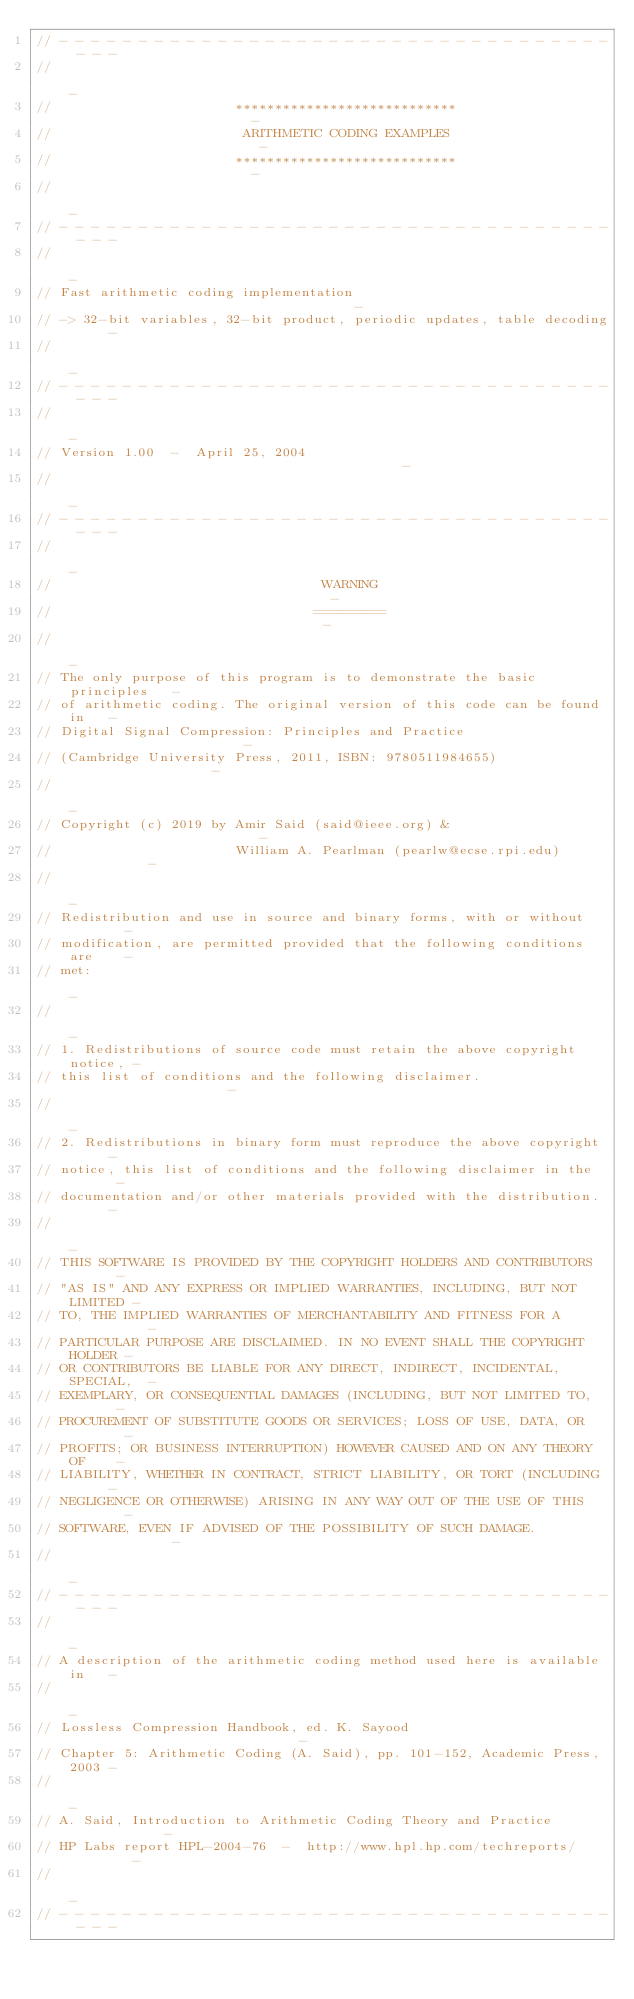Convert code to text. <code><loc_0><loc_0><loc_500><loc_500><_C_>// - - - - - - - - - - - - - - - - - - - - - - - - - - - - - - - - - - - - - -
//                                                                           -
//                       ****************************                        -
//                        ARITHMETIC CODING EXAMPLES                         -
//                       ****************************                        -
//                                                                           -
// - - - - - - - - - - - - - - - - - - - - - - - - - - - - - - - - - - - - - -
//                                                                           -
// Fast arithmetic coding implementation                                     -
// -> 32-bit variables, 32-bit product, periodic updates, table decoding     -
//                                                                           -
// - - - - - - - - - - - - - - - - - - - - - - - - - - - - - - - - - - - - - -
//                                                                           -
// Version 1.00  -  April 25, 2004                                           -
//                                                                           -
// - - - - - - - - - - - - - - - - - - - - - - - - - - - - - - - - - - - - - -
//                                                                           -
//                                  WARNING                                  -
//                                 =========                                 -
//                                                                           -
// The only purpose of this program is to demonstrate the basic principles   -
// of arithmetic coding. The original version of this code can be found in   -
// Digital Signal Compression: Principles and Practice                       -
// (Cambridge University Press, 2011, ISBN: 9780511984655)                   -
//                                                                           -
// Copyright (c) 2019 by Amir Said (said@ieee.org) &                         -
//                       William A. Pearlman (pearlw@ecse.rpi.edu)           -
//                                                                           -
// Redistribution and use in source and binary forms, with or without        -
// modification, are permitted provided that the following conditions are    -
// met:                                                                      -
//                                                                           -
// 1. Redistributions of source code must retain the above copyright notice, -
// this list of conditions and the following disclaimer.                     -
//                                                                           -
// 2. Redistributions in binary form must reproduce the above copyright      -
// notice, this list of conditions and the following disclaimer in the       -
// documentation and/or other materials provided with the distribution.      -
//                                                                           -
// THIS SOFTWARE IS PROVIDED BY THE COPYRIGHT HOLDERS AND CONTRIBUTORS       -
// "AS IS" AND ANY EXPRESS OR IMPLIED WARRANTIES, INCLUDING, BUT NOT LIMITED -
// TO, THE IMPLIED WARRANTIES OF MERCHANTABILITY AND FITNESS FOR A           -
// PARTICULAR PURPOSE ARE DISCLAIMED. IN NO EVENT SHALL THE COPYRIGHT HOLDER -
// OR CONTRIBUTORS BE LIABLE FOR ANY DIRECT, INDIRECT, INCIDENTAL, SPECIAL,  -
// EXEMPLARY, OR CONSEQUENTIAL DAMAGES (INCLUDING, BUT NOT LIMITED TO,       -
// PROCUREMENT OF SUBSTITUTE GOODS OR SERVICES; LOSS OF USE, DATA, OR        -
// PROFITS; OR BUSINESS INTERRUPTION) HOWEVER CAUSED AND ON ANY THEORY OF    -
// LIABILITY, WHETHER IN CONTRACT, STRICT LIABILITY, OR TORT (INCLUDING      -
// NEGLIGENCE OR OTHERWISE) ARISING IN ANY WAY OUT OF THE USE OF THIS        -
// SOFTWARE, EVEN IF ADVISED OF THE POSSIBILITY OF SUCH DAMAGE.              -
//                                                                           -
// - - - - - - - - - - - - - - - - - - - - - - - - - - - - - - - - - - - - - -
//                                                                           -
// A description of the arithmetic coding method used here is available in   -
//                                                                           -
// Lossless Compression Handbook, ed. K. Sayood                              -
// Chapter 5: Arithmetic Coding (A. Said), pp. 101-152, Academic Press, 2003 -
//                                                                           -
// A. Said, Introduction to Arithmetic Coding Theory and Practice             -
// HP Labs report HPL-2004-76  -  http://www.hpl.hp.com/techreports/         -
//                                                                           -
// - - - - - - - - - - - - - - - - - - - - - - - - - - - - - - - - - - - - - -

</code> 